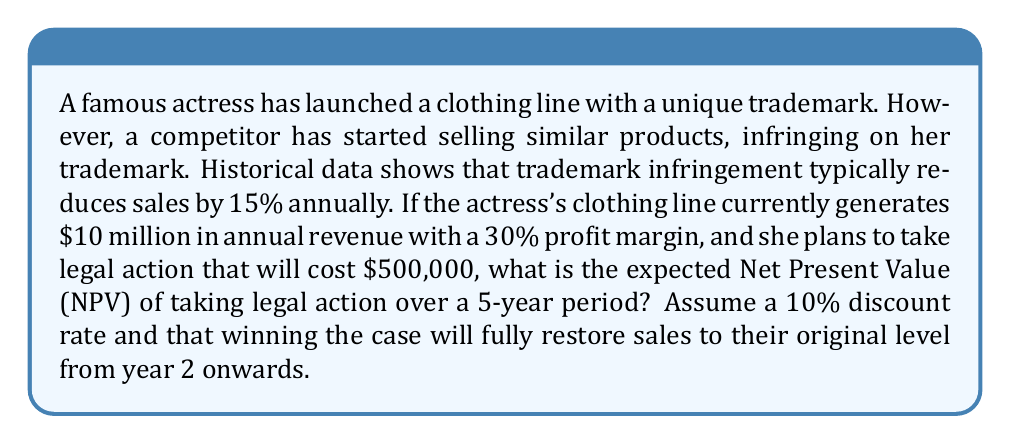Show me your answer to this math problem. Let's approach this problem step-by-step:

1) First, let's calculate the current annual profit:
   Annual Profit = Revenue × Profit Margin
   $$ 10,000,000 \times 0.30 = \$3,000,000 $$

2) If no action is taken, the annual profit with infringement would be:
   $$ 10,000,000 \times 0.85 \times 0.30 = \$2,550,000 $$

3) The cash flows for taking legal action would be:
   Year 0: -$500,000 (legal costs)
   Year 1: $2,550,000 (infringement still affecting sales)
   Years 2-5: $3,000,000 (sales restored to original level)

4) To calculate NPV, we use the formula:
   $$ NPV = \sum_{t=0}^{n} \frac{CF_t}{(1+r)^t} $$
   Where $CF_t$ is the cash flow at time t, r is the discount rate, and n is the number of periods.

5) Let's calculate the NPV:
   $$ NPV = -500,000 + \frac{2,550,000}{1.1} + \frac{3,000,000}{1.1^2} + \frac{3,000,000}{1.1^3} + \frac{3,000,000}{1.1^4} + \frac{3,000,000}{1.1^5} $$

6) Simplifying:
   $$ NPV = -500,000 + 2,318,181.82 + 2,479,338.84 + 2,253,944.40 + 2,049,040.36 + 1,862,764.87 $$

7) Adding these values:
   $$ NPV = 10,463,270.29 $$
Answer: The expected Net Present Value (NPV) of taking legal action over a 5-year period is approximately $10,463,270. 